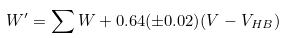<formula> <loc_0><loc_0><loc_500><loc_500>W ^ { \prime } = \sum { W } + 0 . 6 4 ( \pm 0 . 0 2 ) ( V - V _ { H B } )</formula> 